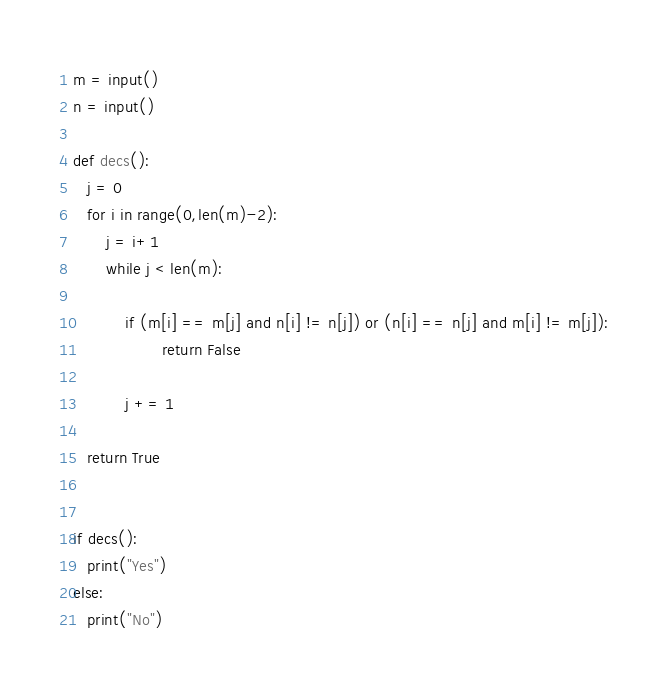Convert code to text. <code><loc_0><loc_0><loc_500><loc_500><_Python_>m = input()
n = input()
 
def decs():
   j = 0
   for i in range(0,len(m)-2):
       j = i+1
       while j < len(m):
           
           if (m[i] == m[j] and n[i] != n[j]) or (n[i] == n[j] and m[i] != m[j]):
                   return False
               
           j += 1
 
   return True
           
   
if decs():
   print("Yes")
else:
   print("No")</code> 